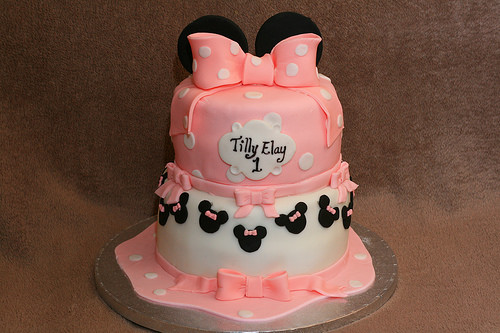<image>
Is there a cake behind the frosting? No. The cake is not behind the frosting. From this viewpoint, the cake appears to be positioned elsewhere in the scene. 